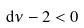Convert formula to latex. <formula><loc_0><loc_0><loc_500><loc_500>d \nu - 2 < 0</formula> 